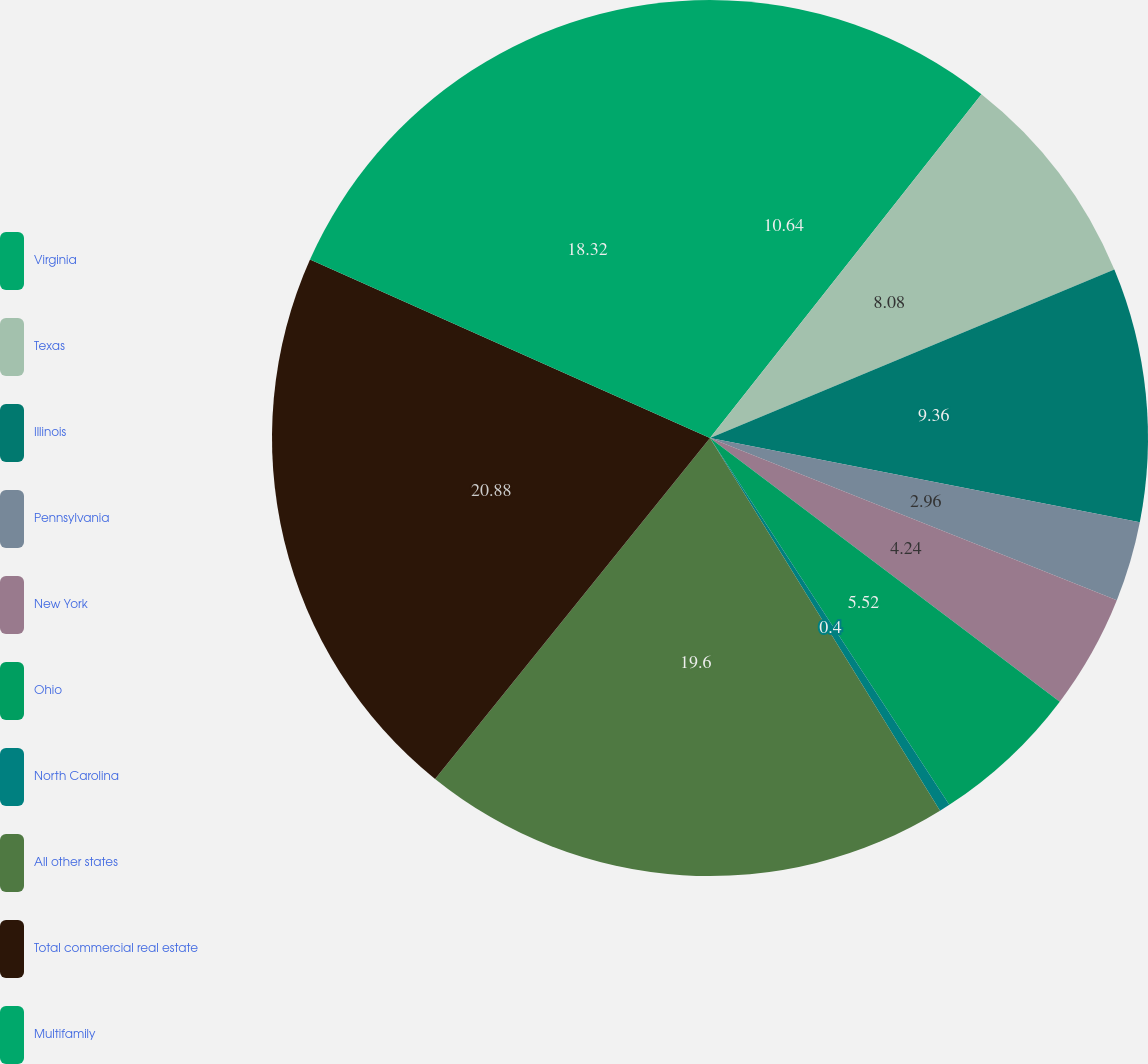<chart> <loc_0><loc_0><loc_500><loc_500><pie_chart><fcel>Virginia<fcel>Texas<fcel>Illinois<fcel>Pennsylvania<fcel>New York<fcel>Ohio<fcel>North Carolina<fcel>All other states<fcel>Total commercial real estate<fcel>Multifamily<nl><fcel>10.64%<fcel>8.08%<fcel>9.36%<fcel>2.96%<fcel>4.24%<fcel>5.52%<fcel>0.4%<fcel>19.6%<fcel>20.88%<fcel>18.32%<nl></chart> 